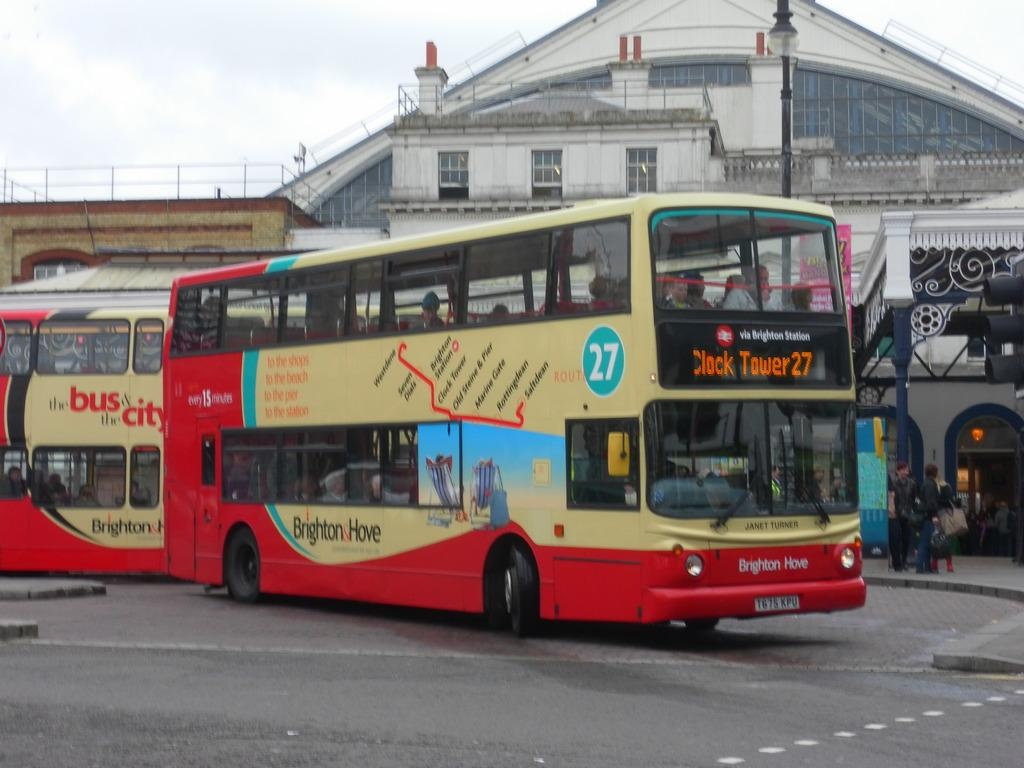<image>
Offer a succinct explanation of the picture presented. The double decker bus is from the Brighton Station. 